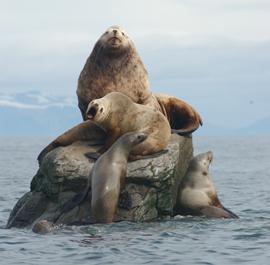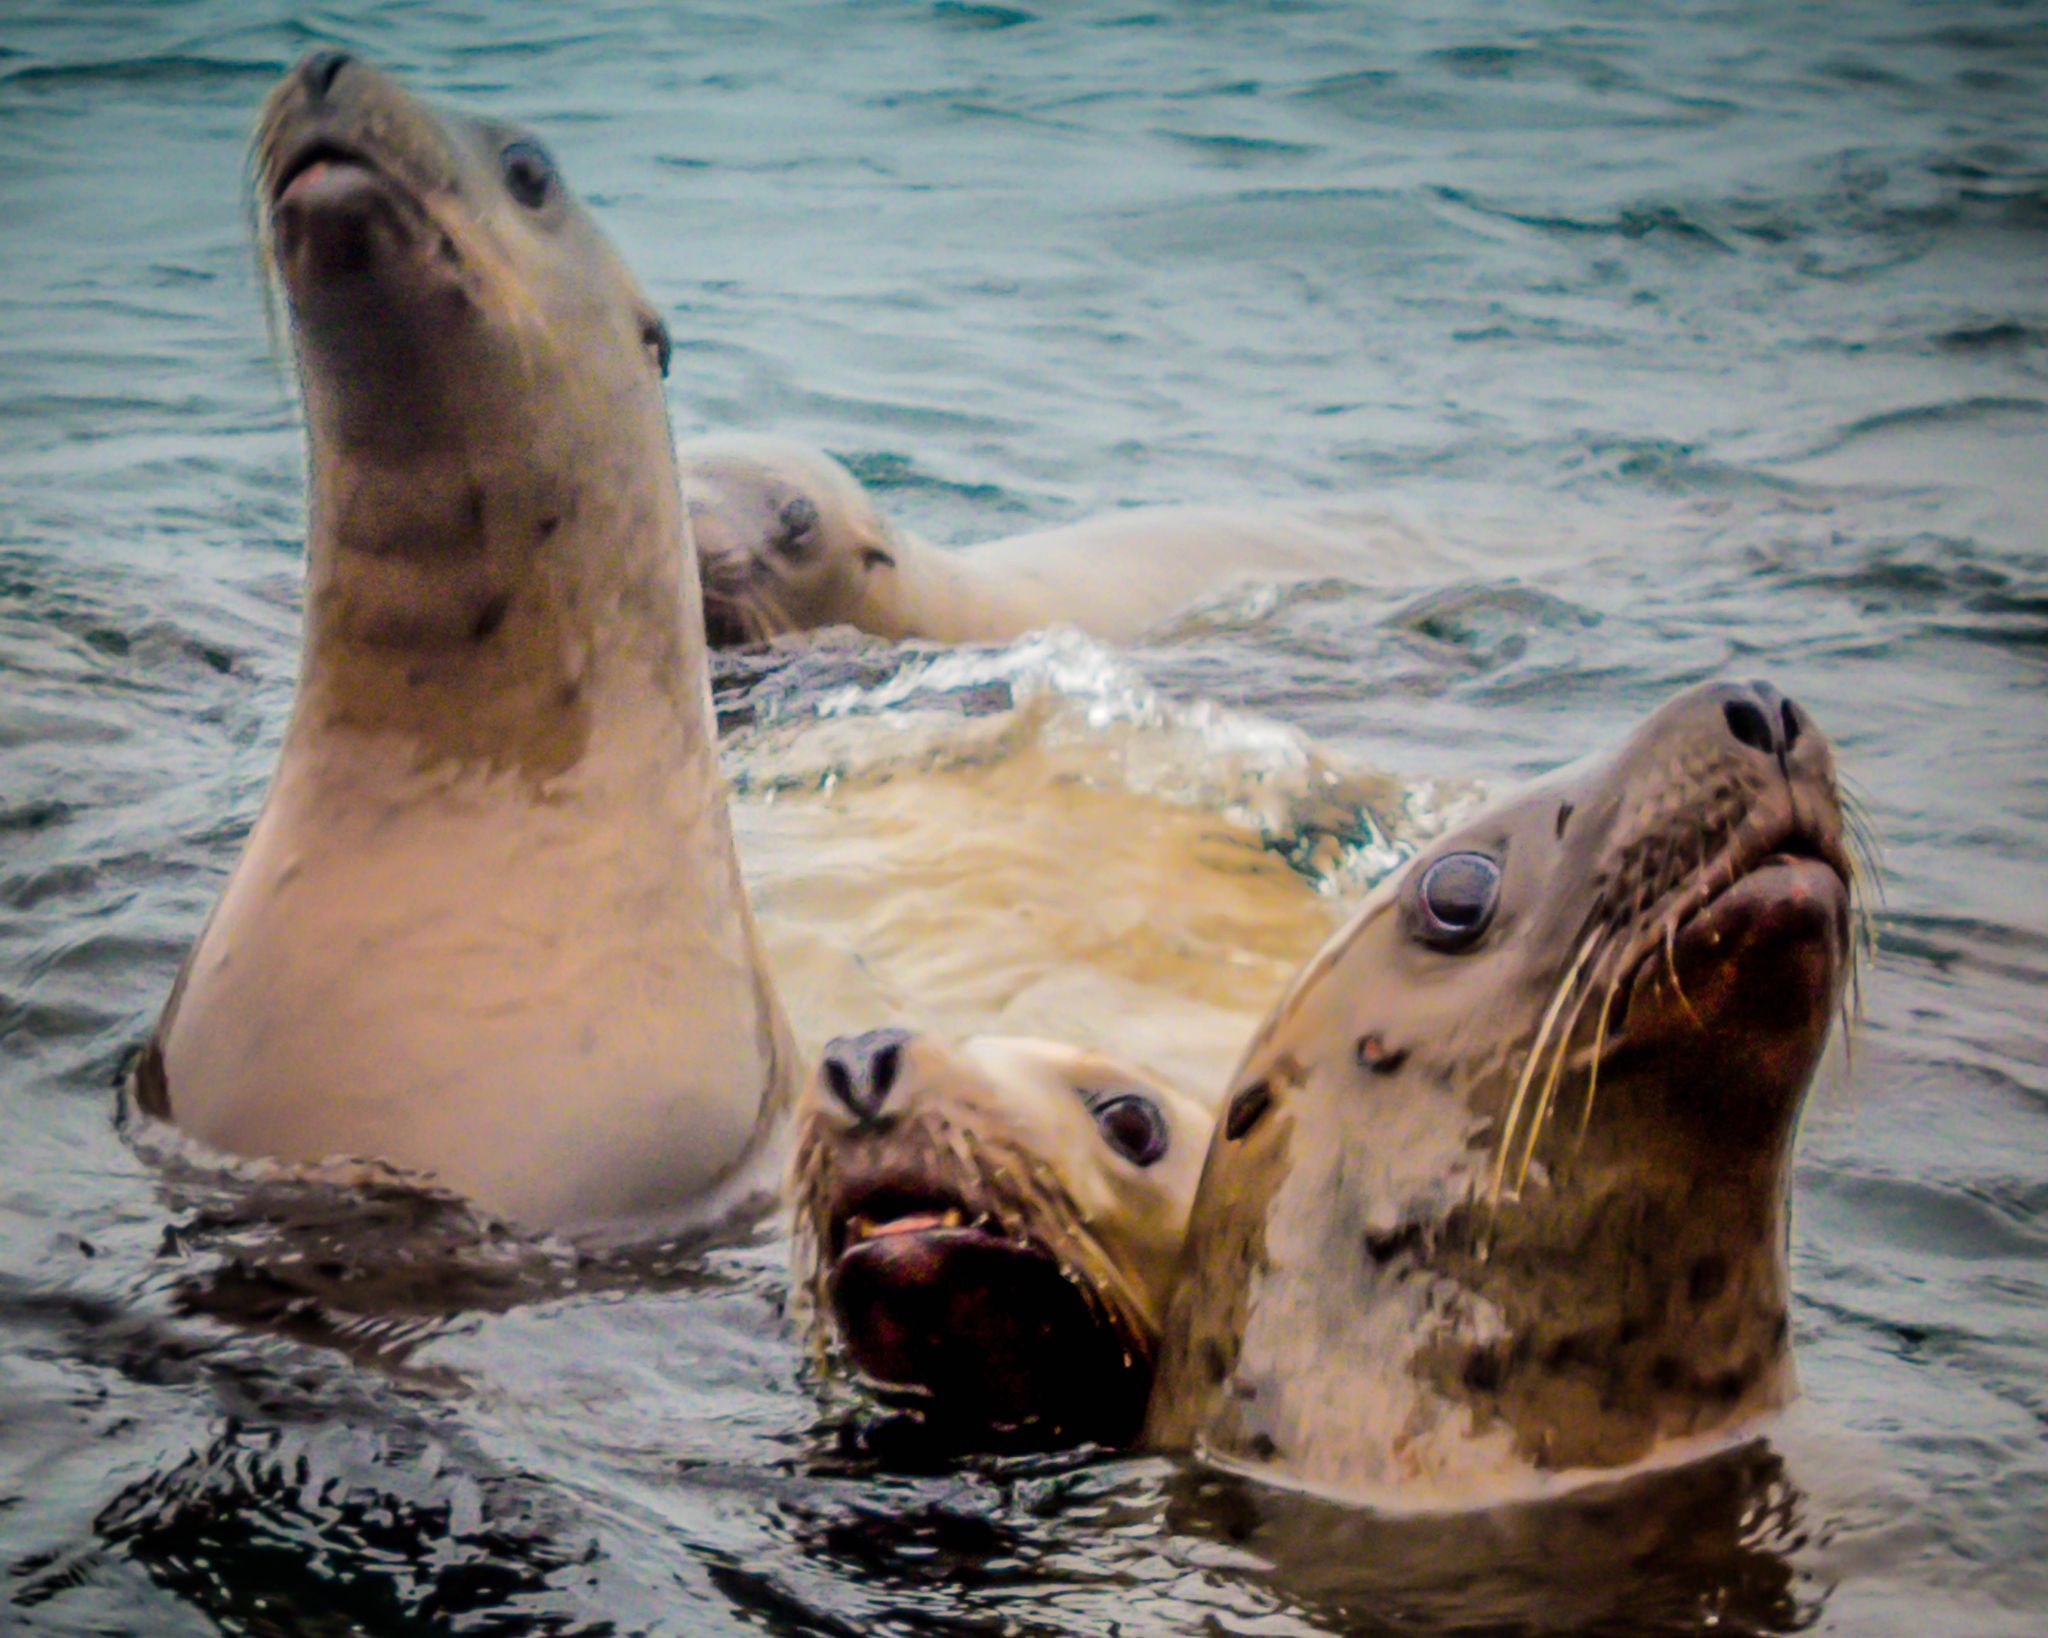The first image is the image on the left, the second image is the image on the right. Evaluate the accuracy of this statement regarding the images: "The right image contains exactly two seals.". Is it true? Answer yes or no. No. 